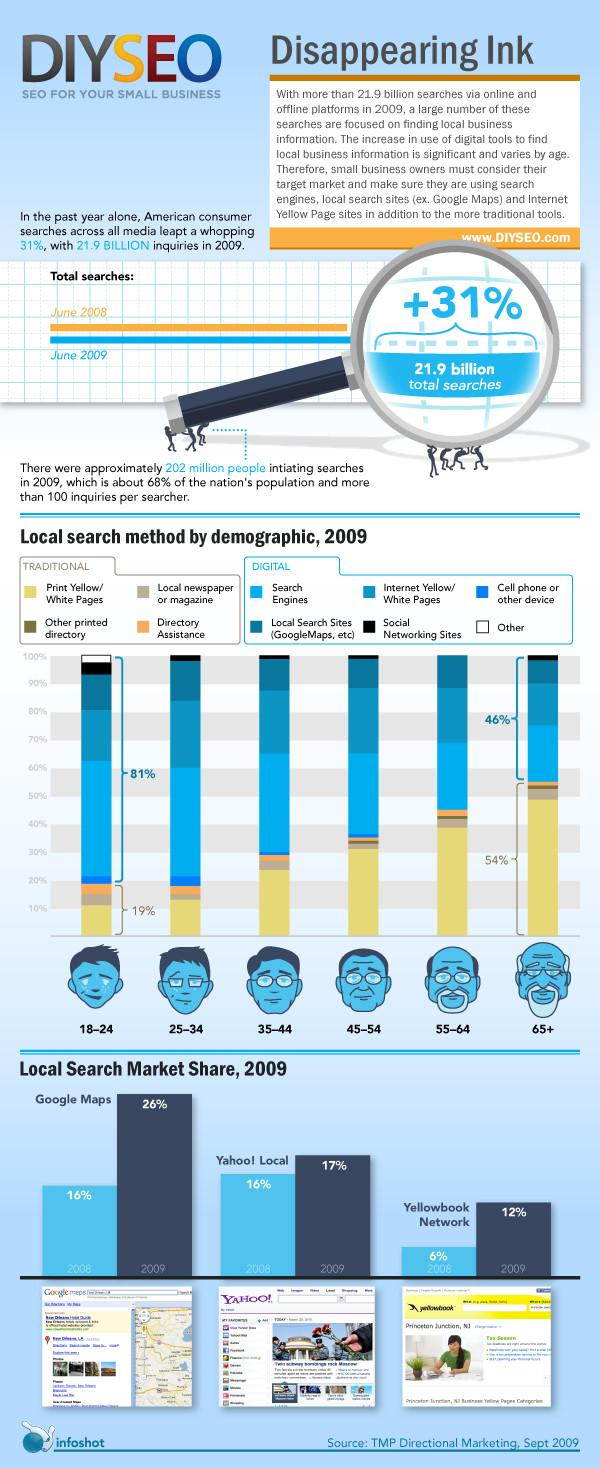Give some essential details in this illustration. According to the data, 18-24-year-olds are the age group that utilizes digital search methods the most. During 2008-2009, Yellowbook Network's market share doubled. In 2008, Google Maps had a 16% market share. In 2009, Yahoo! Local held a market share of 17% in the industry. A recent study found that 46% of senior citizens use digital methods. 